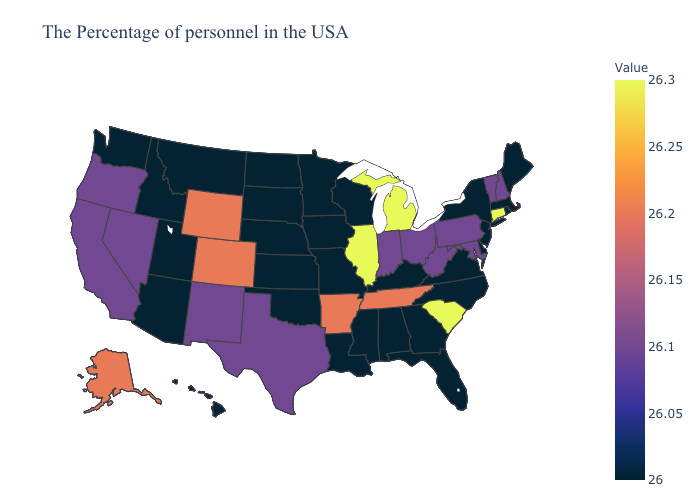Does South Carolina have a lower value than Pennsylvania?
Concise answer only. No. Does Mississippi have the lowest value in the South?
Concise answer only. Yes. Does Indiana have a higher value than Connecticut?
Quick response, please. No. Is the legend a continuous bar?
Concise answer only. Yes. 